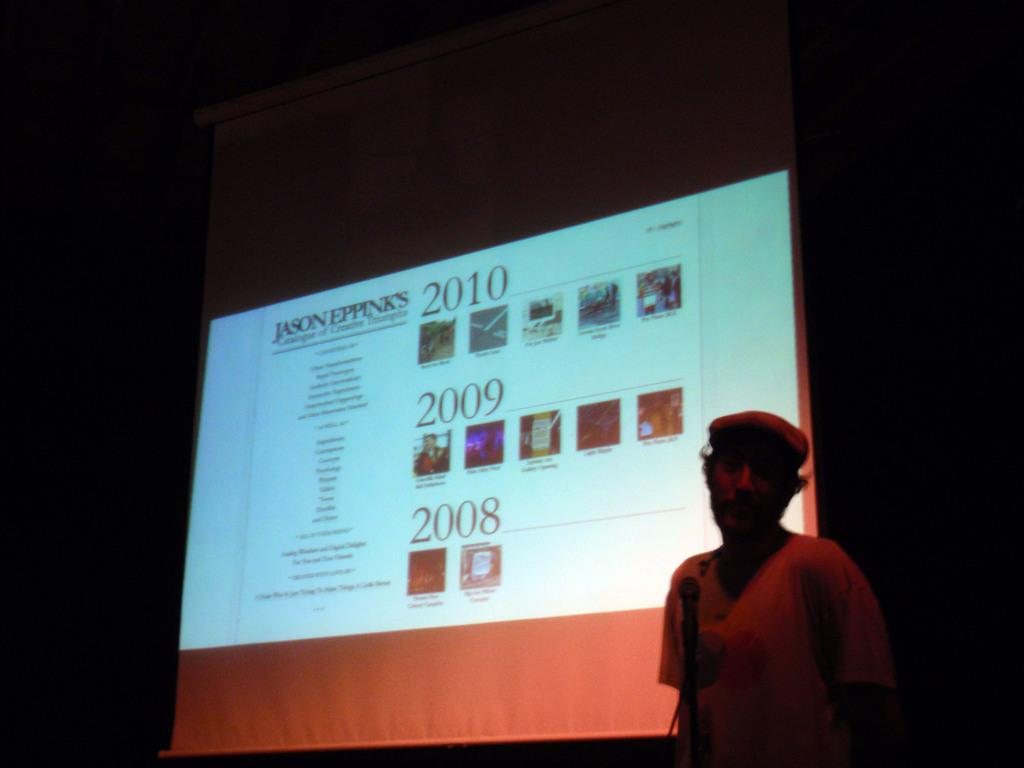What is the main subject of the image? There is a person in the image. What object is visible in the image that is typically used for amplifying sound? There is a microphone in the image. What is the color of the background in the image? The background of the image is dark. What type of device is present in the image that might be used for displaying information or visuals? There is a screen in the image. How many cattle can be seen grazing in the image? There are no cattle present in the image. Is there a cobweb visible in the image? There is no cobweb present in the image. 